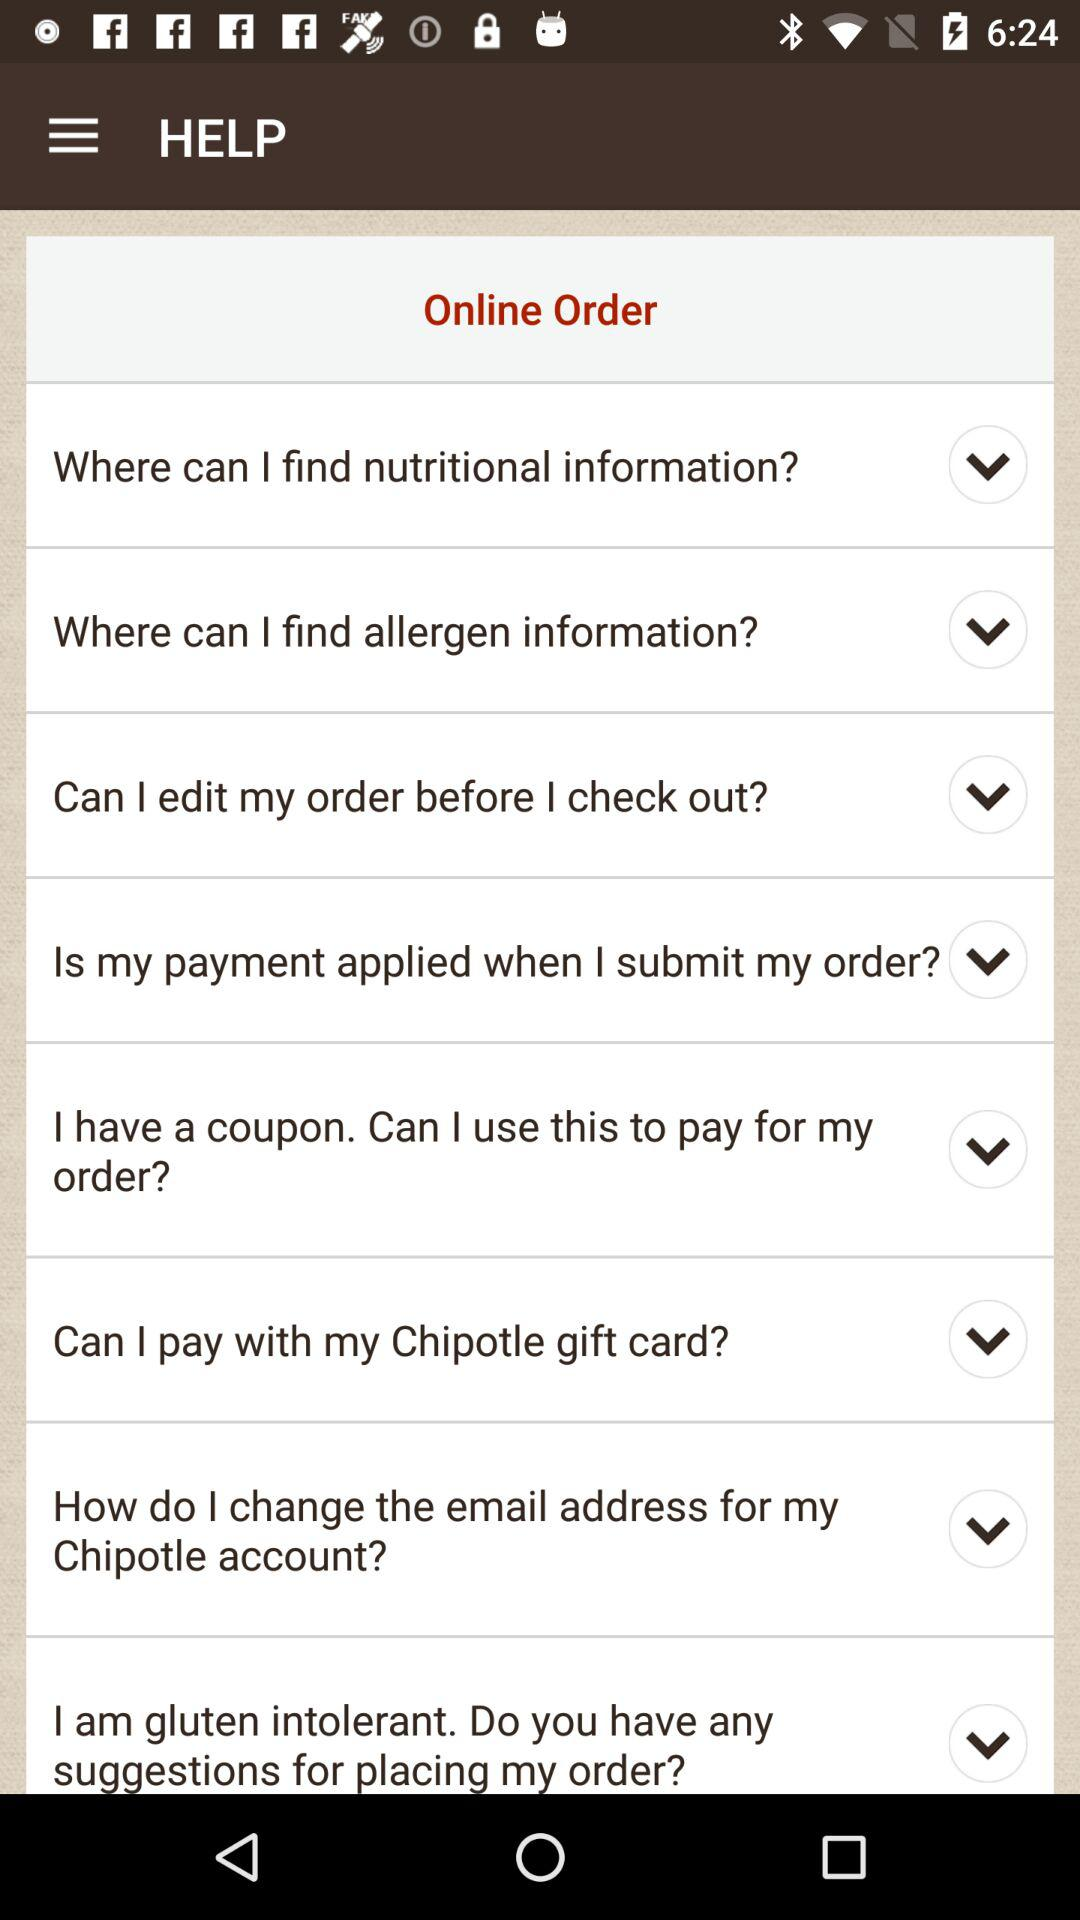How many questions are there in the Help section?
Answer the question using a single word or phrase. 8 